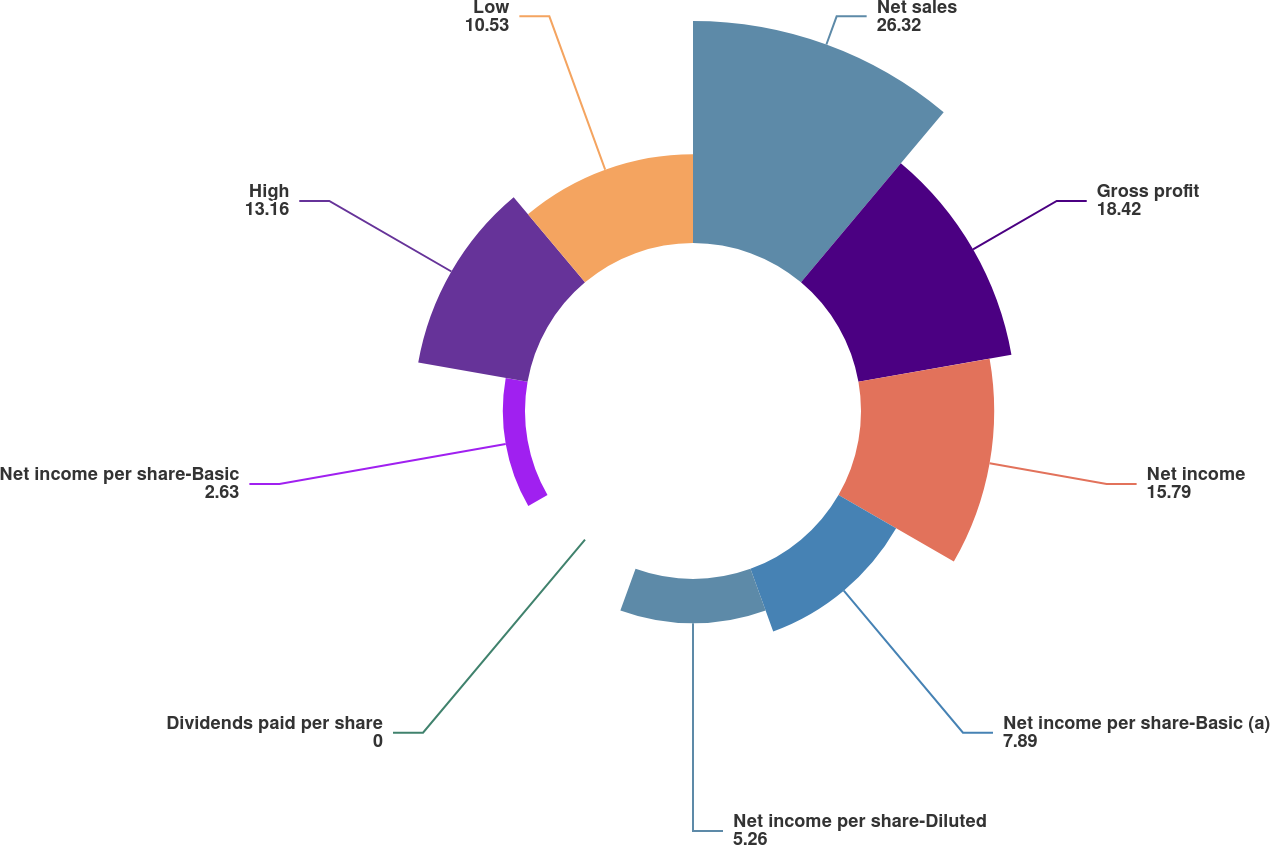Convert chart. <chart><loc_0><loc_0><loc_500><loc_500><pie_chart><fcel>Net sales<fcel>Gross profit<fcel>Net income<fcel>Net income per share-Basic (a)<fcel>Net income per share-Diluted<fcel>Dividends paid per share<fcel>Net income per share-Basic<fcel>High<fcel>Low<nl><fcel>26.32%<fcel>18.42%<fcel>15.79%<fcel>7.89%<fcel>5.26%<fcel>0.0%<fcel>2.63%<fcel>13.16%<fcel>10.53%<nl></chart> 